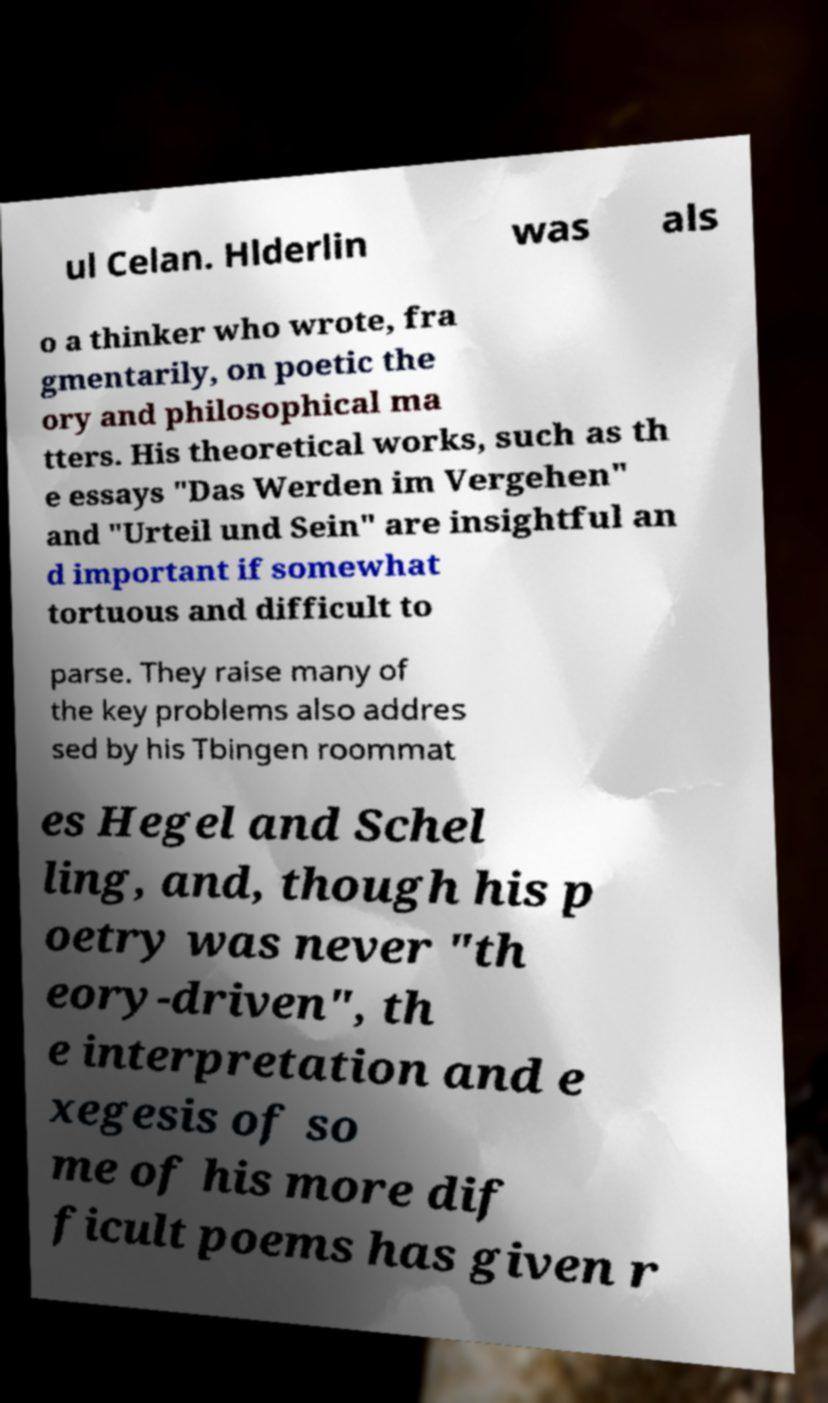I need the written content from this picture converted into text. Can you do that? ul Celan. Hlderlin was als o a thinker who wrote, fra gmentarily, on poetic the ory and philosophical ma tters. His theoretical works, such as th e essays "Das Werden im Vergehen" and "Urteil und Sein" are insightful an d important if somewhat tortuous and difficult to parse. They raise many of the key problems also addres sed by his Tbingen roommat es Hegel and Schel ling, and, though his p oetry was never "th eory-driven", th e interpretation and e xegesis of so me of his more dif ficult poems has given r 